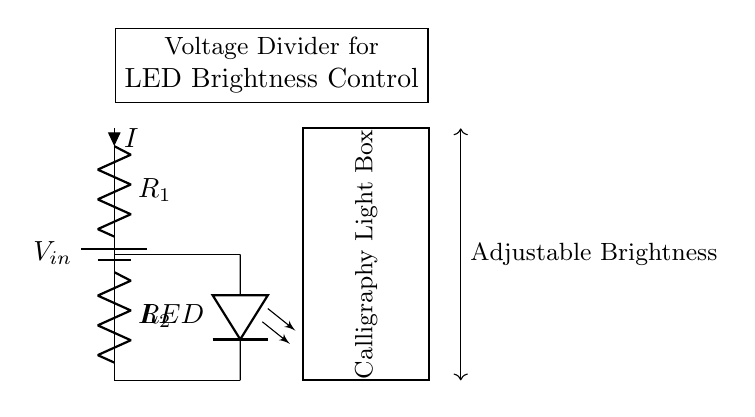What is the power source in this circuit? The circuit includes a battery labeled V_in, which serves as the power source for the entire system.
Answer: Battery What are the resistors in this circuit? The circuit contains two resistors labeled R_1 and R_2 in series, which form the voltage divider.
Answer: R_1 and R_2 What is the role of the LED in this circuit? The LED is connected in such a way that it receives the voltage output from the voltage divider, allowing it to illuminate at a brightness determined by the resistor values.
Answer: Illumination What is the purpose of the voltage divider in this circuit? The voltage divider reduces the input voltage from the battery to a lower output voltage that is suitable for controlling the brightness of the LED.
Answer: Brightness control If R_1 is doubled, what happens to the LED brightness? Increasing R_1 reduces the output voltage across the LED, which in turn decreases the current flowing through it, resulting in dimmer LED brightness.
Answer: Dimmer What does the rectangle represent in the circuit? The rectangle is labeled as the "Calligraphy Light Box," indicating it is the housing for the circuitry and LED, used for illumination in calligraphy work.
Answer: Calligraphy Light Box What does the arrow between R_1 and R_2 indicate? The arrow indicates the direction of current flow (I) through the resistors from the positive terminal of the battery to the ground, essential for understanding the operation of the voltage divider.
Answer: Current direction 